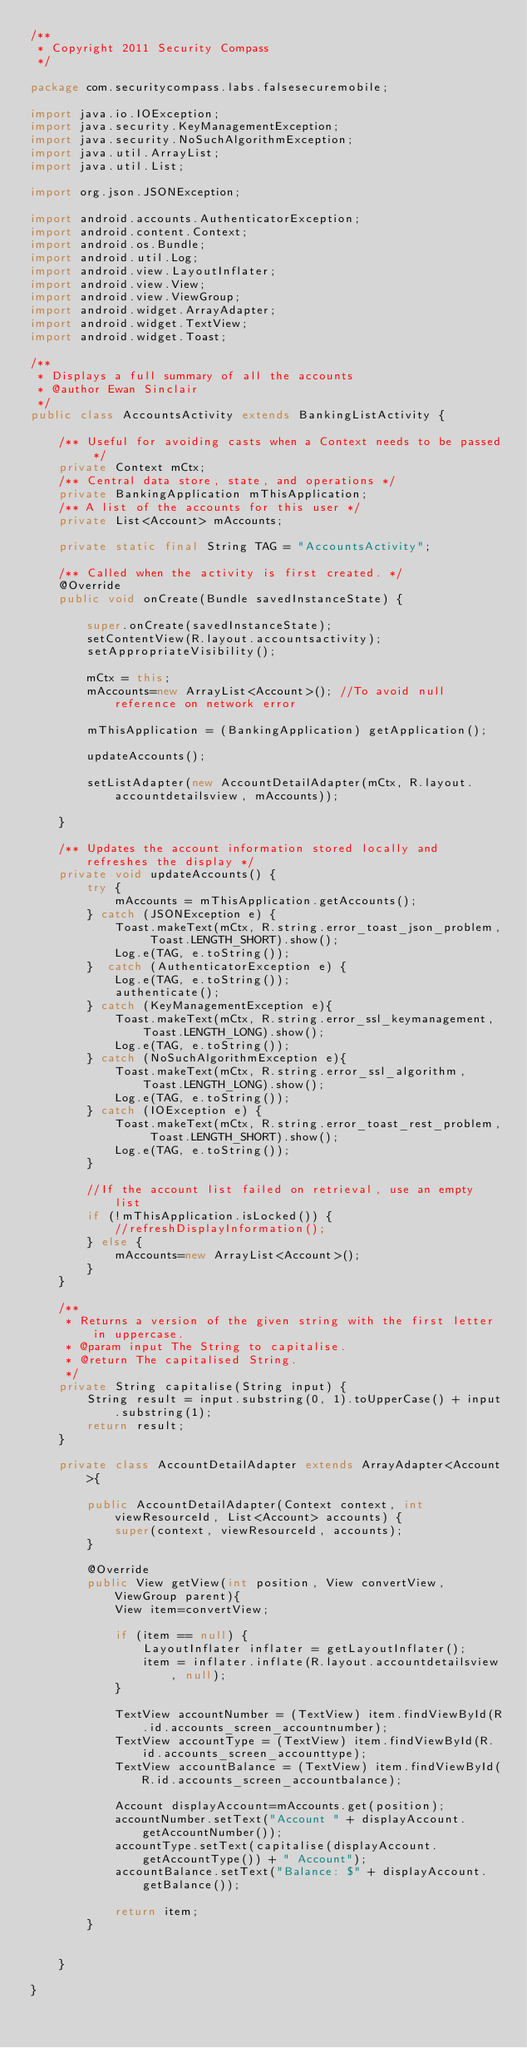<code> <loc_0><loc_0><loc_500><loc_500><_Java_>/**
 * Copyright 2011 Security Compass
 */

package com.securitycompass.labs.falsesecuremobile;

import java.io.IOException;
import java.security.KeyManagementException;
import java.security.NoSuchAlgorithmException;
import java.util.ArrayList;
import java.util.List;

import org.json.JSONException;

import android.accounts.AuthenticatorException;
import android.content.Context;
import android.os.Bundle;
import android.util.Log;
import android.view.LayoutInflater;
import android.view.View;
import android.view.ViewGroup;
import android.widget.ArrayAdapter;
import android.widget.TextView;
import android.widget.Toast;

/**
 * Displays a full summary of all the accounts
 * @author Ewan Sinclair
 */
public class AccountsActivity extends BankingListActivity {

    /** Useful for avoiding casts when a Context needs to be passed */
    private Context mCtx;
    /** Central data store, state, and operations */
    private BankingApplication mThisApplication;
    /** A list of the accounts for this user */
    private List<Account> mAccounts;
    
    private static final String TAG = "AccountsActivity";

    /** Called when the activity is first created. */
    @Override
    public void onCreate(Bundle savedInstanceState) {

        super.onCreate(savedInstanceState);
        setContentView(R.layout.accountsactivity);
        setAppropriateVisibility();

        mCtx = this;
        mAccounts=new ArrayList<Account>(); //To avoid null reference on network error
        
        mThisApplication = (BankingApplication) getApplication();
        
        updateAccounts();
        
        setListAdapter(new AccountDetailAdapter(mCtx, R.layout.accountdetailsview, mAccounts));
        
    }

    /** Updates the account information stored locally and refreshes the display */
    private void updateAccounts() {
        try {
            mAccounts = mThisApplication.getAccounts();
        } catch (JSONException e) {
            Toast.makeText(mCtx, R.string.error_toast_json_problem, Toast.LENGTH_SHORT).show();
            Log.e(TAG, e.toString());
        }  catch (AuthenticatorException e) {
            Log.e(TAG, e.toString());
            authenticate();
        } catch (KeyManagementException e){
            Toast.makeText(mCtx, R.string.error_ssl_keymanagement, Toast.LENGTH_LONG).show();
            Log.e(TAG, e.toString());
        } catch (NoSuchAlgorithmException e){
            Toast.makeText(mCtx, R.string.error_ssl_algorithm, Toast.LENGTH_LONG).show();
            Log.e(TAG, e.toString());
        } catch (IOException e) {
            Toast.makeText(mCtx, R.string.error_toast_rest_problem, Toast.LENGTH_SHORT).show();
            Log.e(TAG, e.toString());
        }

        //If the account list failed on retrieval, use an empty list
        if (!mThisApplication.isLocked()) {
            //refreshDisplayInformation();
        } else {
            mAccounts=new ArrayList<Account>();
        }
    }
   
    /**
     * Returns a version of the given string with the first letter in uppercase.
     * @param input The String to capitalise.
     * @return The capitalised String.
     */
    private String capitalise(String input) {
        String result = input.substring(0, 1).toUpperCase() + input.substring(1);
        return result;
    }

    private class AccountDetailAdapter extends ArrayAdapter<Account>{
        
        public AccountDetailAdapter(Context context, int viewResourceId, List<Account> accounts) {
            super(context, viewResourceId, accounts);
        }

        @Override
        public View getView(int position, View convertView, ViewGroup parent){
            View item=convertView;
            
            if (item == null) {
                LayoutInflater inflater = getLayoutInflater();
                item = inflater.inflate(R.layout.accountdetailsview, null);
            }
            
            TextView accountNumber = (TextView) item.findViewById(R.id.accounts_screen_accountnumber);
            TextView accountType = (TextView) item.findViewById(R.id.accounts_screen_accounttype);
            TextView accountBalance = (TextView) item.findViewById(R.id.accounts_screen_accountbalance);
            
            Account displayAccount=mAccounts.get(position);
            accountNumber.setText("Account " + displayAccount.getAccountNumber());
            accountType.setText(capitalise(displayAccount.getAccountType()) + " Account");
            accountBalance.setText("Balance: $" + displayAccount.getBalance());
            
            return item;
        }
        
        
    }
    
}
</code> 